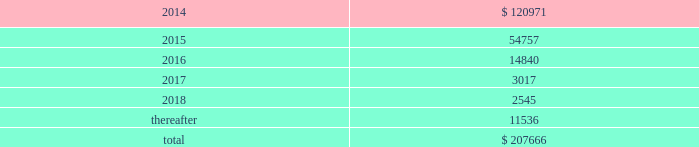Interest expense related to capital lease obligations was $ 1.7 million during both the years ended december 31 , 2013 and 2012 , and $ 1.5 million during the year ended december 31 , 2011 .
Purchase commitments in the table below , we set forth our enforceable and legally binding purchase obligations as of december 31 , 2013 .
Some of the amounts included in the table are based on management 2019s estimates and assumptions about these obligations , including their duration , the possibility of renewal , anticipated actions by third parties , and other factors .
Because these estimates and assumptions are necessarily subjective , our actual payments may vary from those reflected in the table .
Purchase orders made in the ordinary course of business are excluded from the table below .
Any amounts for which we are liable under purchase orders are reflected on the consolidated balance sheets as accounts payable and accrued liabilities .
These obligations relate to various purchase agreements for items such as minimum amounts of fiber and energy purchases over periods ranging from one to 15 years .
Total purchase commitments are as follows ( dollars in thousands ) : .
The company purchased a total of $ 61.7 million , $ 27.7 million , and $ 28.5 million during the years ended december 31 , 2013 , 2012 , and 2011 , respectively , under these purchase agreements .
The increase in purchase commitments in 2014 , compared with 2013 , relates to the acquisition of boise in fourth quarter 2013 .
Environmental liabilities the potential costs for various environmental matters are uncertain due to such factors as the unknown magnitude of possible cleanup costs , the complexity and evolving nature of governmental laws and regulations and their interpretations , and the timing , varying costs and effectiveness of alternative cleanup technologies .
From 1994 through 2013 , remediation costs at the company 2019s mills and corrugated plants totaled approximately $ 3.2 million .
At december 31 , 2013 , the company had $ 34.1 million of environmental-related reserves recorded on its consolidated balance sheet .
Of the $ 34.1 million , approximately $ 26.5 million related to environmental- related asset retirement obligations discussed in note 14 , asset retirement obligations , and $ 7.6 million related to our estimate of other environmental contingencies .
The company recorded $ 7.8 million in 201caccrued liabilities 201d and $ 26.3 million in 201cother long-term liabilities 201d on the consolidated balance sheet .
Liabilities recorded for environmental contingencies are estimates of the probable costs based upon available information and assumptions .
Because of these uncertainties , pca 2019s estimates may change .
As of the date of this filing , the company believes that it is not reasonably possible that future environmental expenditures for remediation costs and asset retirement obligations above the $ 34.1 million accrued as of december 31 , 2013 , will have a material impact on its financial condition , results of operations , or cash flows .
Guarantees and indemnifications we provide guarantees , indemnifications , and other assurances to third parties in the normal course of our business .
These include tort indemnifications , environmental assurances , and representations and warranties in commercial agreements .
At december 31 , 2013 , we are not aware of any material liabilities arising from any guarantee , indemnification , or financial assurance we have provided .
If we determined such a liability was probable and subject to reasonable determination , we would accrue for it at that time. .
In 2015 what was the percent of the purchase commitments of the total purchase commitments? 
Rationale: in 2015 the percent of the purchase commitments of the total purchase commitments was 26.4%
Computations: (54757 / 207666)
Answer: 0.26368. 